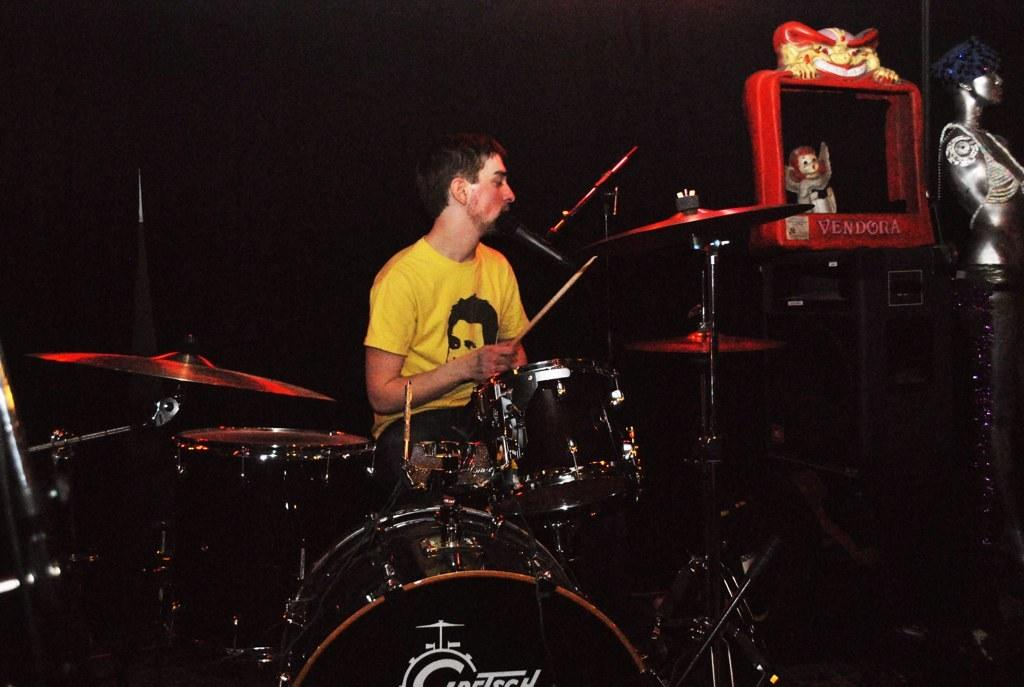What is the main subject of the image? There is a person in the image. What is the person holding in the image? The person is holding a stick. What type of musical instruments can be seen in the image? There are musical drums in the image. What other notable object is present in the image? There is a statue in the image. What type of toy is visible in the image? There is a toy in the image. Can you describe the background of the image? The background of the image is dark. How many horses are visible in the image? There are no horses present in the image. What type of sheet is covering the statue in the image? There is no sheet covering the statue in the image; it is visible without any covering. 